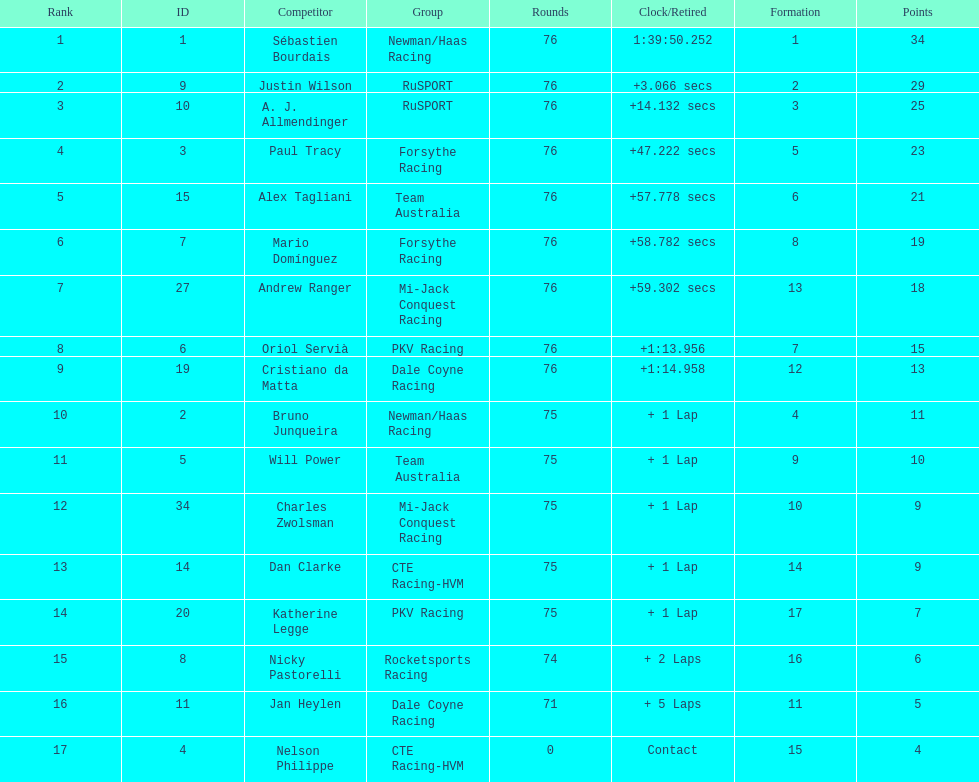How many positions are held by canada? 3. 